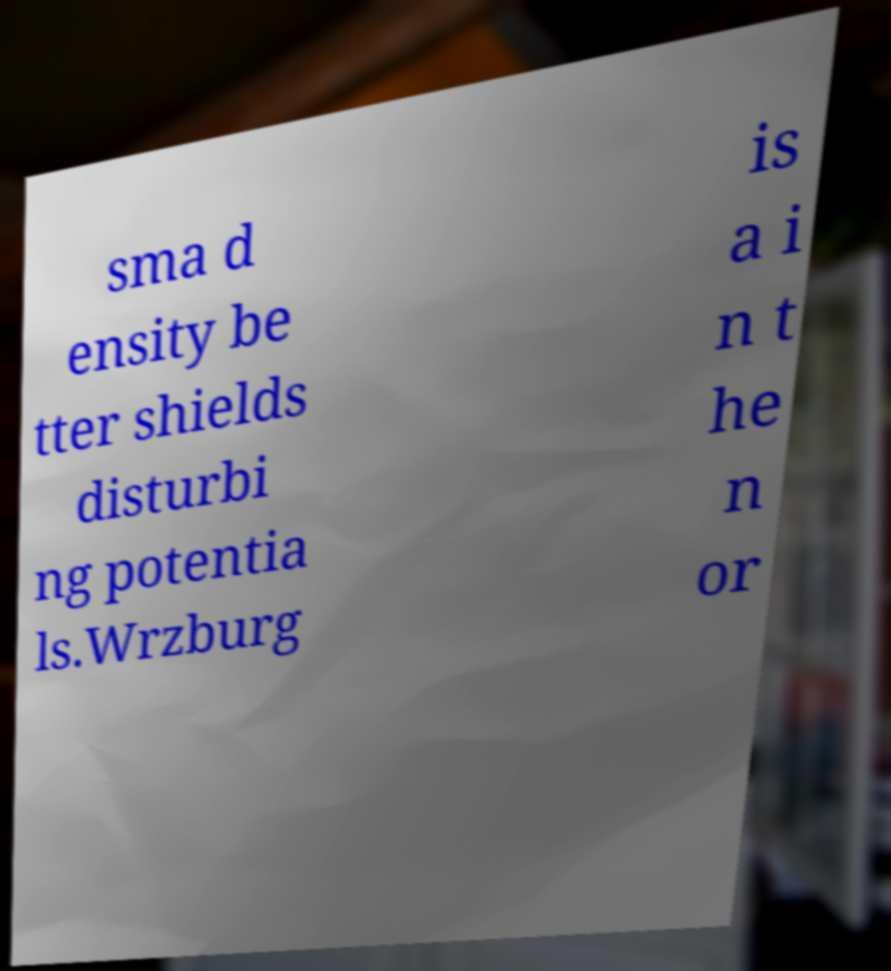Could you extract and type out the text from this image? sma d ensity be tter shields disturbi ng potentia ls.Wrzburg is a i n t he n or 